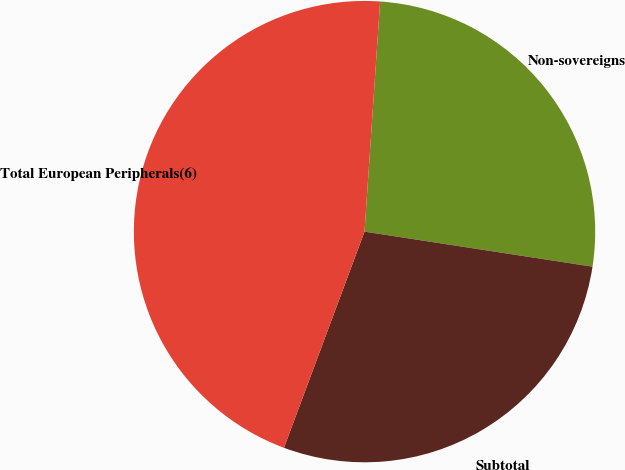Convert chart to OTSL. <chart><loc_0><loc_0><loc_500><loc_500><pie_chart><fcel>Non-sovereigns<fcel>Subtotal<fcel>Total European Peripherals(6)<nl><fcel>26.35%<fcel>28.25%<fcel>45.4%<nl></chart> 